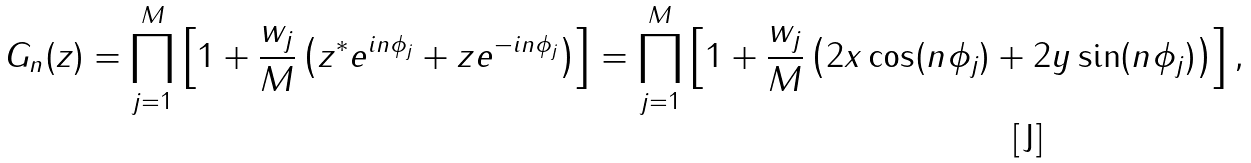<formula> <loc_0><loc_0><loc_500><loc_500>G _ { n } ( z ) = \prod _ { j = 1 } ^ { M } \left [ 1 + \frac { w _ { j } } { M } \left ( z ^ { * } e ^ { i n \phi _ { j } } + z e ^ { - i n \phi _ { j } } \right ) \right ] = \prod _ { j = 1 } ^ { M } \left [ 1 + \frac { w _ { j } } { M } \left ( 2 x \cos ( n \phi _ { j } ) + 2 y \sin ( n \phi _ { j } ) \right ) \right ] ,</formula> 